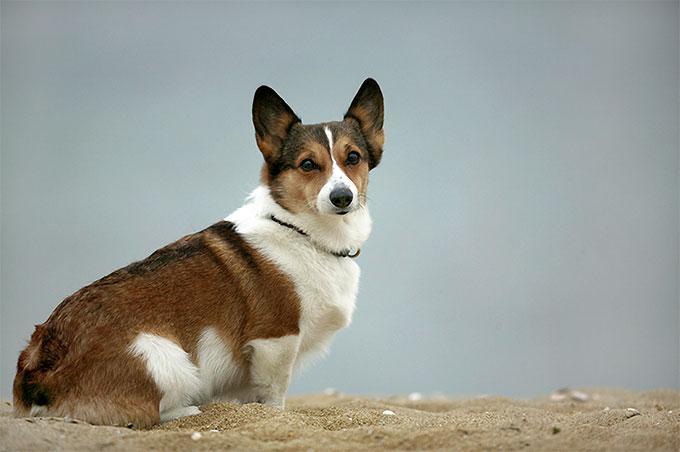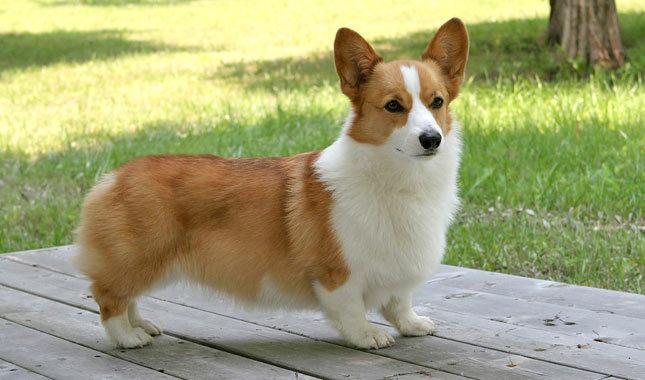The first image is the image on the left, the second image is the image on the right. Assess this claim about the two images: "Neither dog is walking or running.". Correct or not? Answer yes or no. Yes. The first image is the image on the left, the second image is the image on the right. Given the left and right images, does the statement "Each image shows exactly one corgi dog outdoors on grass." hold true? Answer yes or no. No. The first image is the image on the left, the second image is the image on the right. Assess this claim about the two images: "In one of the images there is a single corgi sitting on the ground outside.". Correct or not? Answer yes or no. Yes. 